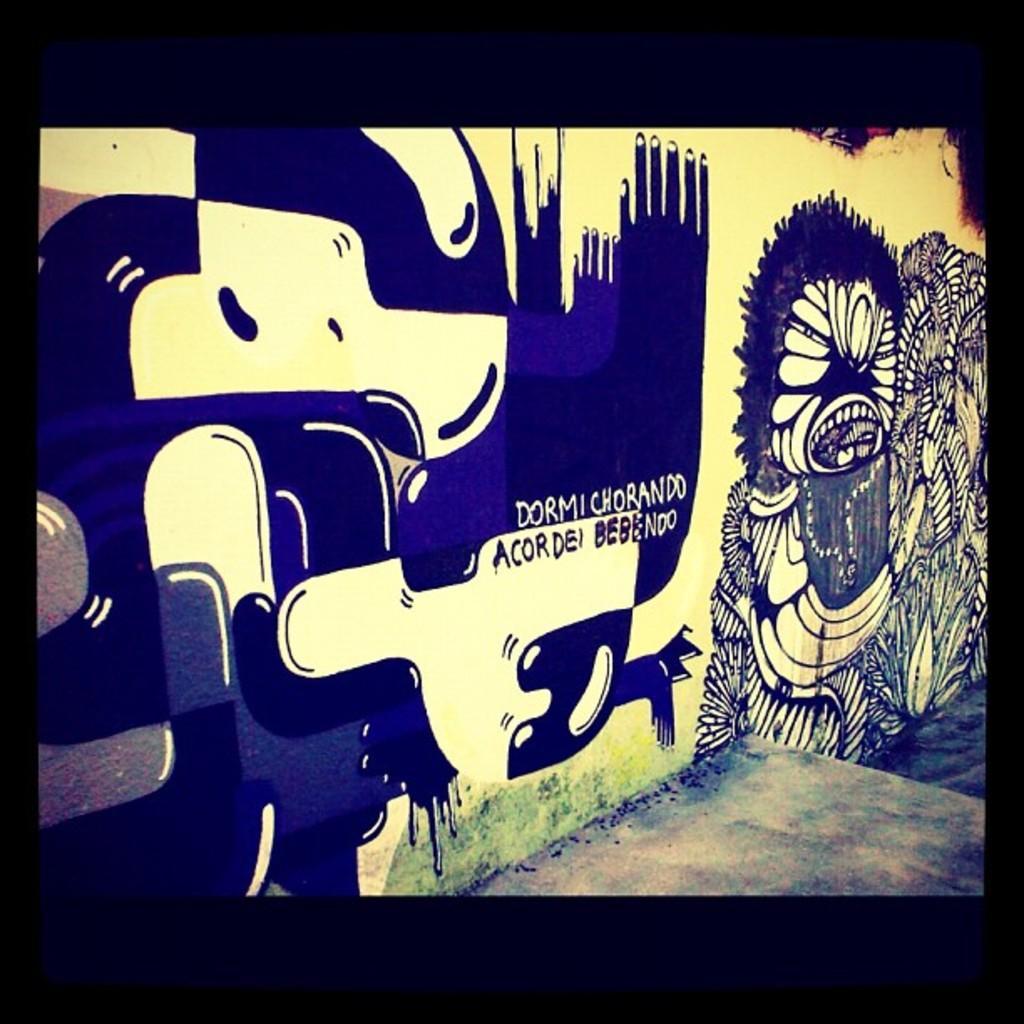Please provide a concise description of this image. In this image there is a wall having some painting of few images and some text. Bottom of the image there is a floor. 